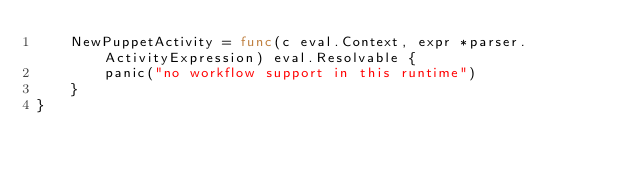<code> <loc_0><loc_0><loc_500><loc_500><_Go_>	NewPuppetActivity = func(c eval.Context, expr *parser.ActivityExpression) eval.Resolvable {
		panic("no workflow support in this runtime")
	}
}
</code> 